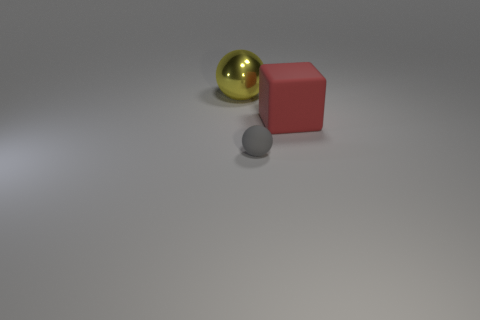Add 3 metallic spheres. How many objects exist? 6 Subtract all balls. How many objects are left? 1 Subtract 0 green blocks. How many objects are left? 3 Subtract all tiny purple shiny spheres. Subtract all large rubber cubes. How many objects are left? 2 Add 2 large red things. How many large red things are left? 3 Add 3 big purple shiny things. How many big purple shiny things exist? 3 